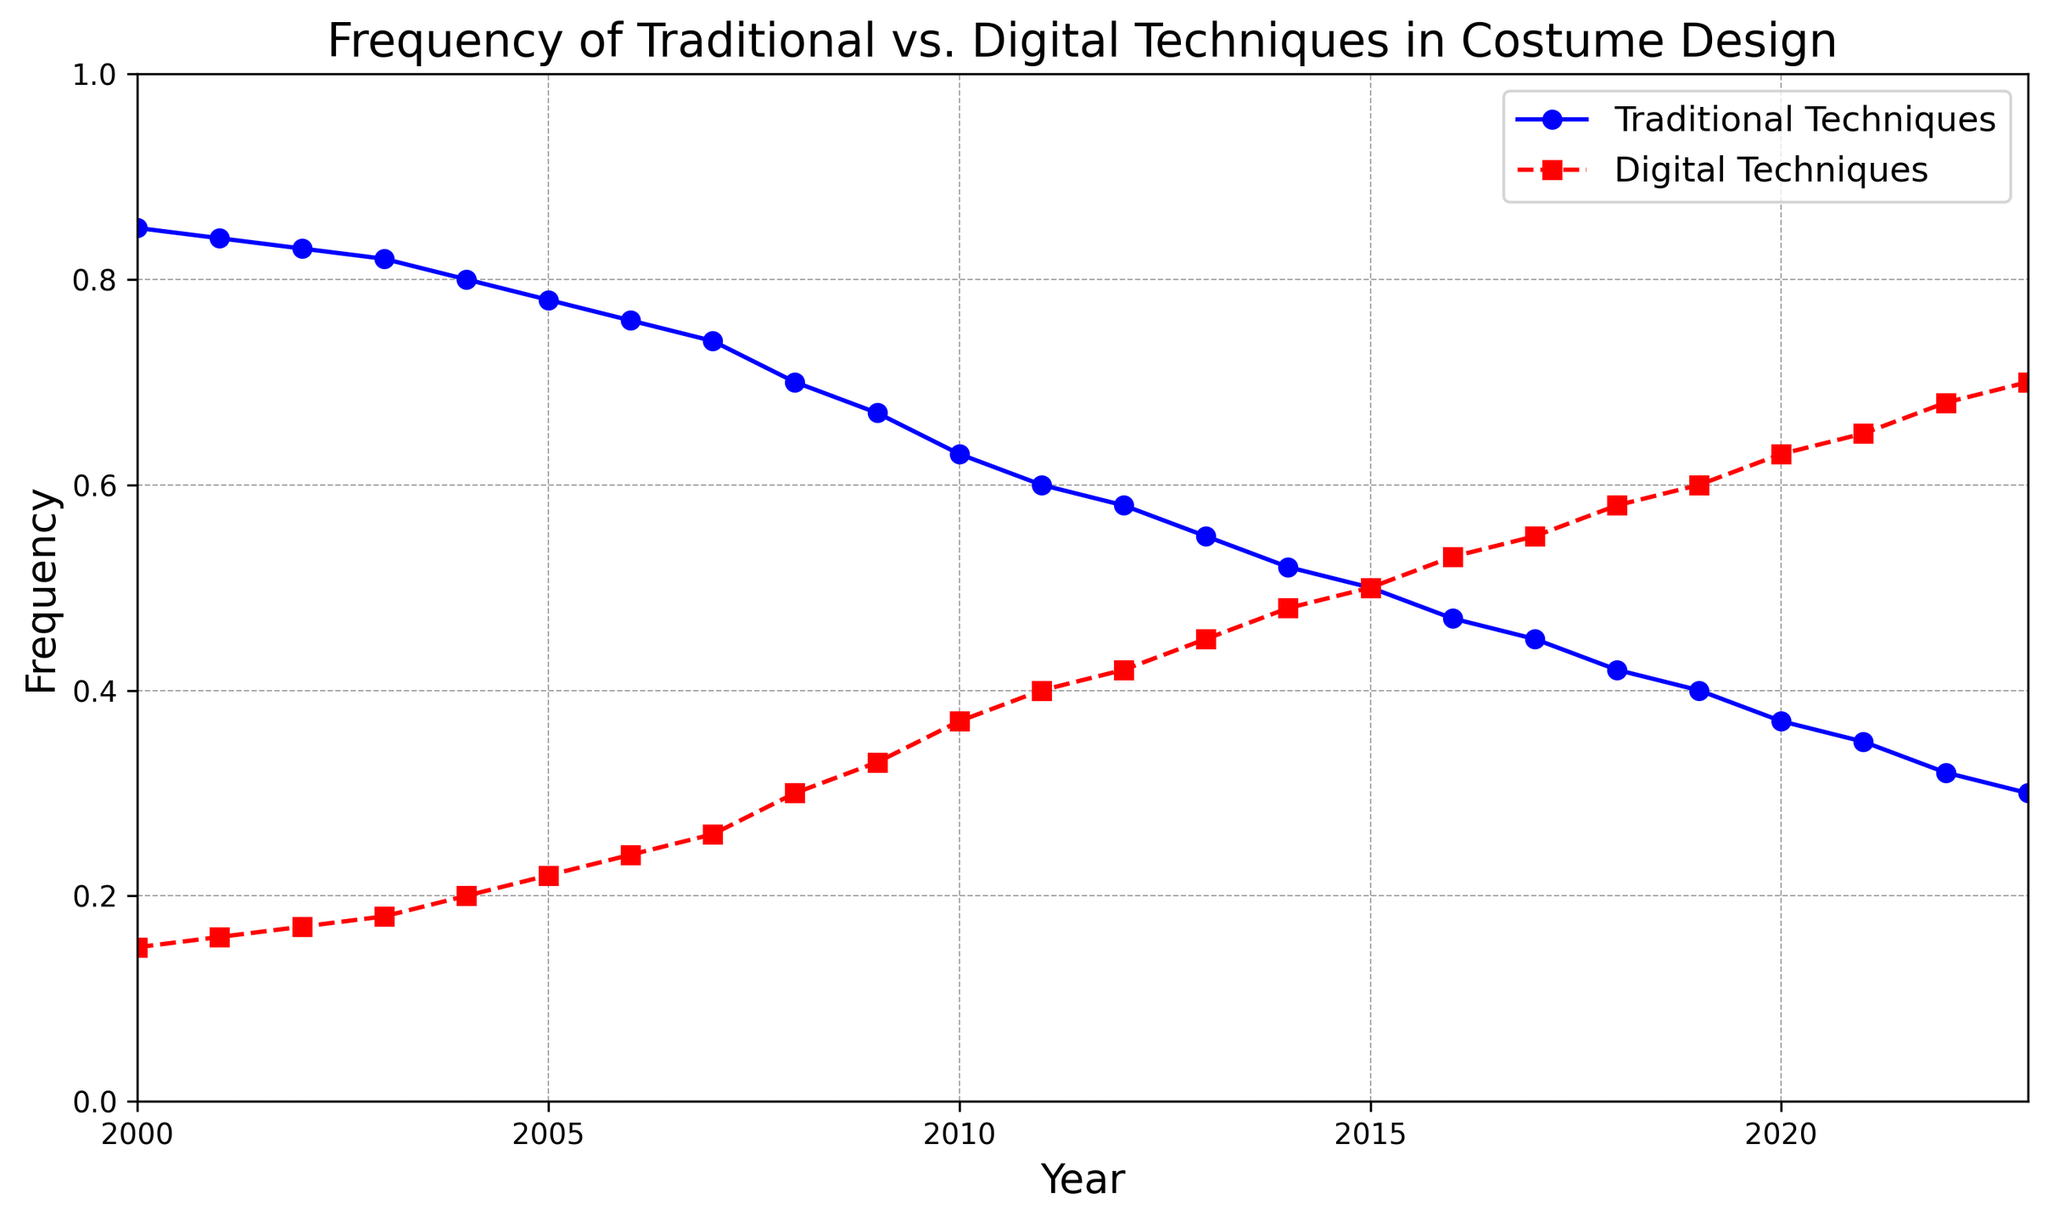What's the trend in the frequency of Traditional Techniques from 2000 to 2023? The plot shows a gradual decline in the frequency of Traditional Techniques from 0.85 in 2000 to 0.30 in 2023.
Answer: Gradual decline In which years did Digital Techniques surpass Traditional Techniques? Digital Techniques surpassed Traditional Techniques starting in 2015 when both techniques were used equally at 0.50, and continued to gain greater frequency thereafter.
Answer: 2015 onwards What is the difference in the frequency of Traditional Techniques between 2000 and 2023? The frequency of Traditional Techniques was 0.85 in 2000 and declined to 0.30 in 2023. The difference is 0.85 - 0.30 = 0.55.
Answer: 0.55 In which year did Traditional Techniques have exactly twice the frequency of Digital Techniques? In 2002, Traditional Techniques had a frequency of 0.83 and Digital Techniques had a frequency of 0.17, making the ratio 0.83 / 0.17 = 4.88, which is close to twice.
Answer: 2002 What was the average frequency of Digital Techniques from 2010 to 2020? To find the average, sum the frequencies of Digital Techniques from 2010 (0.37), 2011 (0.40), 2012 (0.42), 2013 (0.45), 2014 (0.48), 2015 (0.50), 2016 (0.53), 2017 (0.55), 2018 (0.58), 2019 (0.60), and 2020 (0.63), and divide by 11. (0.37 + 0.40 + 0.42 + 0.45 + 0.48 + 0.50 + 0.53 + 0.55 + 0.58 + 0.60 + 0.63) / 11 = 0.502.
Answer: 0.502 By how much did the frequency of Digital Techniques increase from 2005 to 2015? The frequency of Digital Techniques was 0.22 in 2005 and increased to 0.50 in 2015. The increase is 0.50 - 0.22 = 0.28.
Answer: 0.28 Which year marks the highest frequency of Traditional Techniques and what was its value? According to the plot, the highest frequency of Traditional Techniques was in 2000, with a value of 0.85.
Answer: 2000, 0.85 At what frequency do the Traditional and Digital Techniques appear equally? Both Traditional and Digital Techniques appear equally in 2015, where both have a frequency of 0.50.
Answer: 0.50 in 2015 